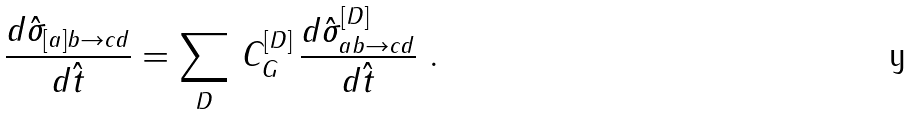<formula> <loc_0><loc_0><loc_500><loc_500>\frac { d \hat { \sigma } _ { [ a ] b \rightarrow c d } } { d \hat { t } } = \sum _ { D } \, C _ { G } ^ { [ D ] } \, \frac { d \hat { \sigma } ^ { [ D ] } _ { a b \rightarrow c d } } { d \hat { t } } \ .</formula> 